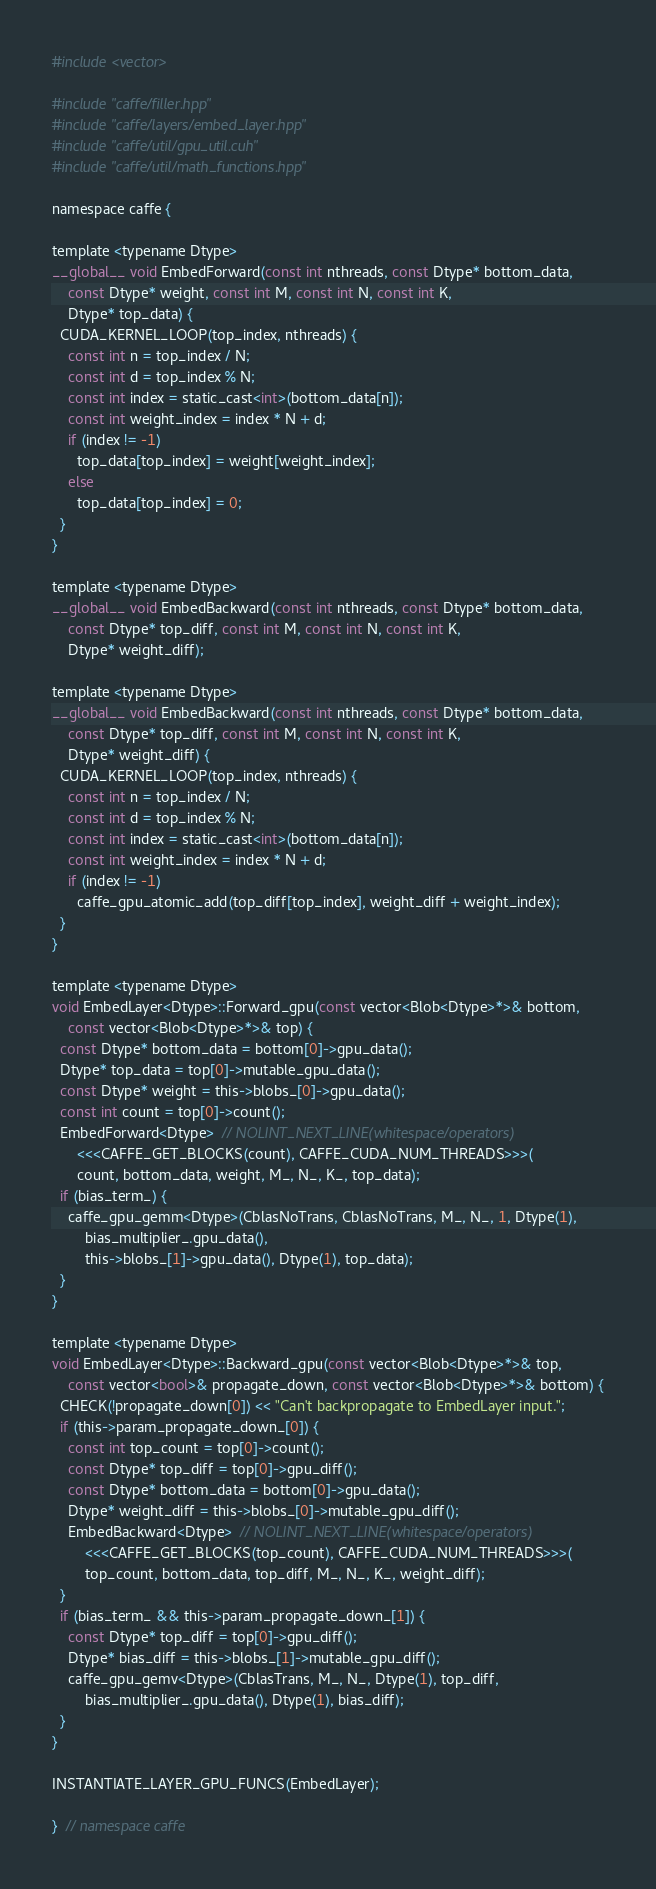Convert code to text. <code><loc_0><loc_0><loc_500><loc_500><_Cuda_>#include <vector>

#include "caffe/filler.hpp"
#include "caffe/layers/embed_layer.hpp"
#include "caffe/util/gpu_util.cuh"
#include "caffe/util/math_functions.hpp"

namespace caffe {

template <typename Dtype>
__global__ void EmbedForward(const int nthreads, const Dtype* bottom_data,
    const Dtype* weight, const int M, const int N, const int K,
    Dtype* top_data) {
  CUDA_KERNEL_LOOP(top_index, nthreads) {
    const int n = top_index / N;
    const int d = top_index % N;
    const int index = static_cast<int>(bottom_data[n]);
    const int weight_index = index * N + d;
    if (index != -1)
      top_data[top_index] = weight[weight_index];
    else
      top_data[top_index] = 0;
  }
}

template <typename Dtype>
__global__ void EmbedBackward(const int nthreads, const Dtype* bottom_data,
    const Dtype* top_diff, const int M, const int N, const int K,
    Dtype* weight_diff);

template <typename Dtype>
__global__ void EmbedBackward(const int nthreads, const Dtype* bottom_data,
    const Dtype* top_diff, const int M, const int N, const int K,
    Dtype* weight_diff) {
  CUDA_KERNEL_LOOP(top_index, nthreads) {
    const int n = top_index / N;
    const int d = top_index % N;
    const int index = static_cast<int>(bottom_data[n]);
    const int weight_index = index * N + d;
    if (index != -1)
      caffe_gpu_atomic_add(top_diff[top_index], weight_diff + weight_index);
  }
}

template <typename Dtype>
void EmbedLayer<Dtype>::Forward_gpu(const vector<Blob<Dtype>*>& bottom,
    const vector<Blob<Dtype>*>& top) {
  const Dtype* bottom_data = bottom[0]->gpu_data();
  Dtype* top_data = top[0]->mutable_gpu_data();
  const Dtype* weight = this->blobs_[0]->gpu_data();
  const int count = top[0]->count();
  EmbedForward<Dtype>  // NOLINT_NEXT_LINE(whitespace/operators)
      <<<CAFFE_GET_BLOCKS(count), CAFFE_CUDA_NUM_THREADS>>>(
      count, bottom_data, weight, M_, N_, K_, top_data);
  if (bias_term_) {
    caffe_gpu_gemm<Dtype>(CblasNoTrans, CblasNoTrans, M_, N_, 1, Dtype(1),
        bias_multiplier_.gpu_data(),
        this->blobs_[1]->gpu_data(), Dtype(1), top_data);
  }
}

template <typename Dtype>
void EmbedLayer<Dtype>::Backward_gpu(const vector<Blob<Dtype>*>& top,
    const vector<bool>& propagate_down, const vector<Blob<Dtype>*>& bottom) {
  CHECK(!propagate_down[0]) << "Can't backpropagate to EmbedLayer input.";
  if (this->param_propagate_down_[0]) {
    const int top_count = top[0]->count();
    const Dtype* top_diff = top[0]->gpu_diff();
    const Dtype* bottom_data = bottom[0]->gpu_data();
    Dtype* weight_diff = this->blobs_[0]->mutable_gpu_diff();
    EmbedBackward<Dtype>  // NOLINT_NEXT_LINE(whitespace/operators)
        <<<CAFFE_GET_BLOCKS(top_count), CAFFE_CUDA_NUM_THREADS>>>(
        top_count, bottom_data, top_diff, M_, N_, K_, weight_diff);
  }
  if (bias_term_ && this->param_propagate_down_[1]) {
    const Dtype* top_diff = top[0]->gpu_diff();
    Dtype* bias_diff = this->blobs_[1]->mutable_gpu_diff();
    caffe_gpu_gemv<Dtype>(CblasTrans, M_, N_, Dtype(1), top_diff,
        bias_multiplier_.gpu_data(), Dtype(1), bias_diff);
  }
}

INSTANTIATE_LAYER_GPU_FUNCS(EmbedLayer);

}  // namespace caffe
</code> 